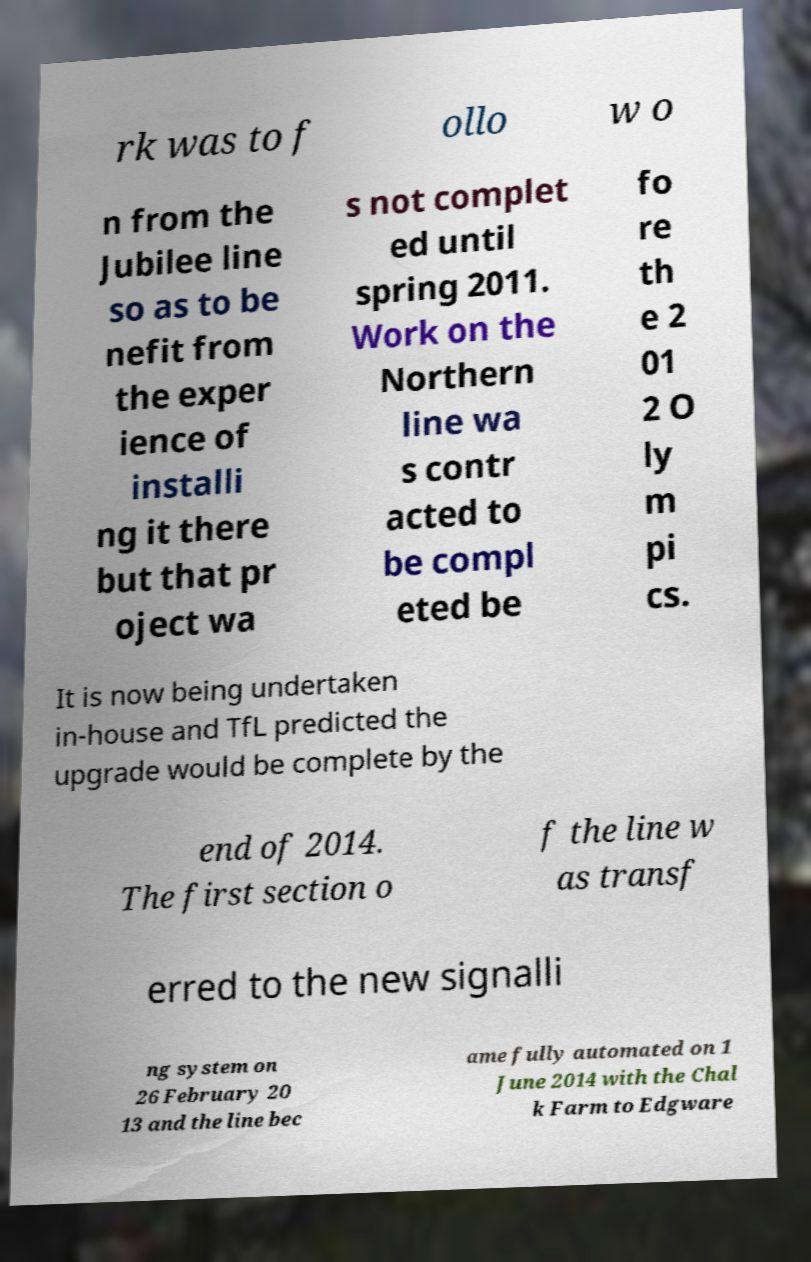Can you accurately transcribe the text from the provided image for me? rk was to f ollo w o n from the Jubilee line so as to be nefit from the exper ience of installi ng it there but that pr oject wa s not complet ed until spring 2011. Work on the Northern line wa s contr acted to be compl eted be fo re th e 2 01 2 O ly m pi cs. It is now being undertaken in-house and TfL predicted the upgrade would be complete by the end of 2014. The first section o f the line w as transf erred to the new signalli ng system on 26 February 20 13 and the line bec ame fully automated on 1 June 2014 with the Chal k Farm to Edgware 